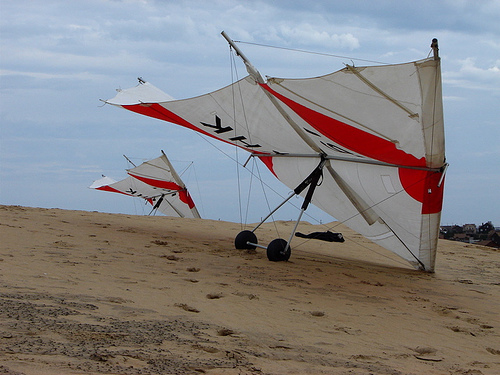<image>
Can you confirm if the sail board is in the sand? No. The sail board is not contained within the sand. These objects have a different spatial relationship. Where is the pipe in relation to the wheel? Is it in front of the wheel? No. The pipe is not in front of the wheel. The spatial positioning shows a different relationship between these objects. 